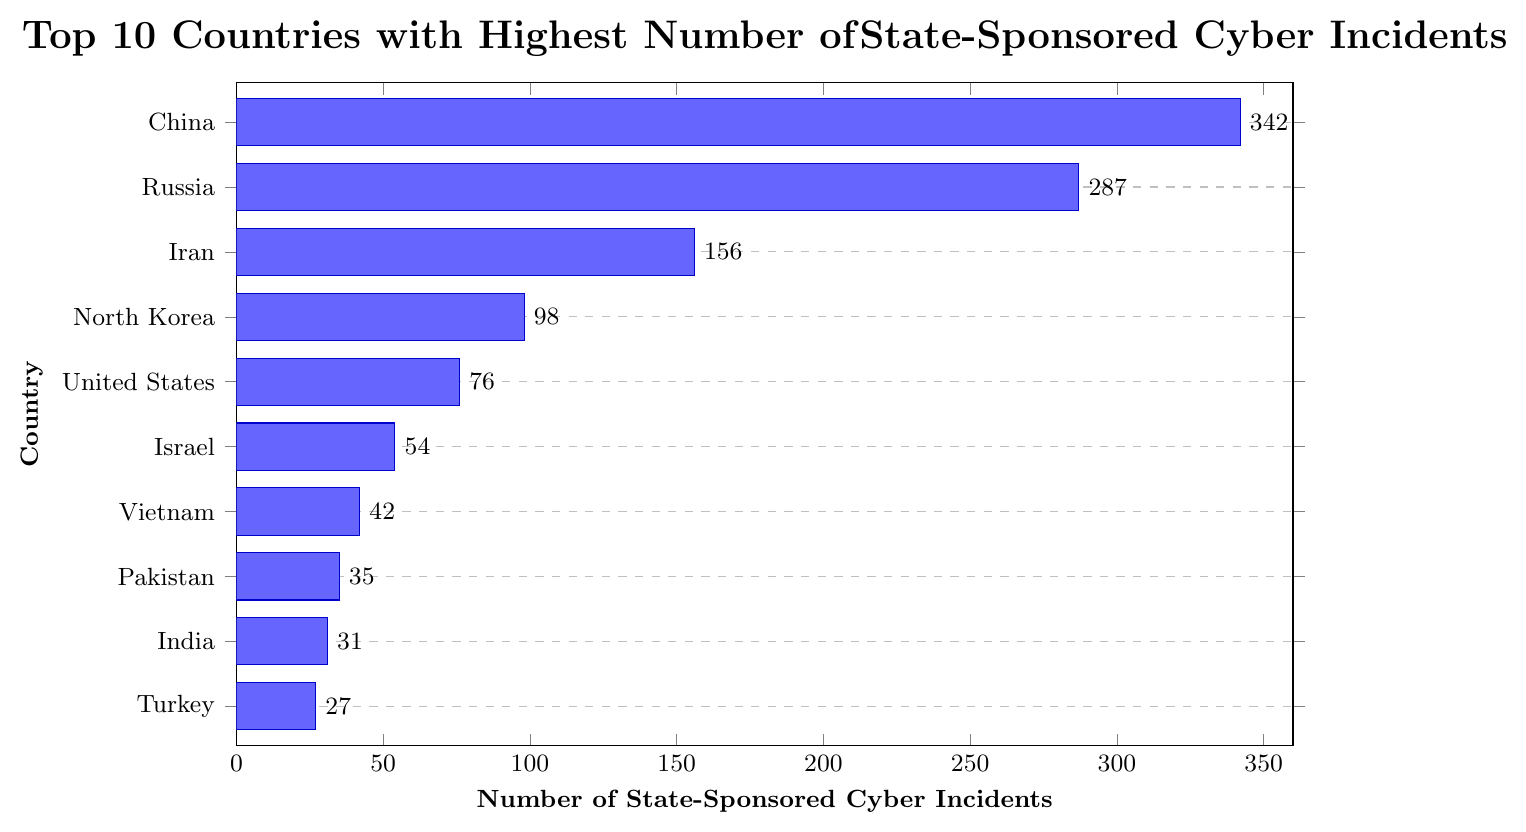What's the total number of state-sponsored cyber incidents for the top three countries? Add the number of incidents for China, Russia, and Iran: 342 (China) + 287 (Russia) + 156 (Iran) = 785
Answer: 785 Which country has more state-sponsored cyber incidents, Iran or North Korea? Iran has 156 incidents and North Korea has 98 incidents. Comparing these values, 156 is greater than 98
Answer: Iran What is the average number of state-sponsored cyber incidents for the top five countries? The top five countries are China, Russia, Iran, North Korea, and the United States. Sum their incidents: 342 + 287 + 156 + 98 + 76 = 959. Divide by 5: 959 / 5 = 191.8
Answer: 191.8 Which country has the lowest number of incidents among the top 10 countries listed? The country with the lowest number of incidents among the top 10 is Turkey, with 27 incidents
Answer: Turkey How many more incidents does China have compared to the United States? China has 342 incidents and the United States has 76 incidents. Subtract the number for the United States from the number for China: 342 - 76 = 266
Answer: 266 What is the difference in the number of incidents between Pakistan and Vietnam? Vietnam has 42 incidents and Pakistan has 35 incidents. Subtract the number for Pakistan from the number for Vietnam: 42 - 35 = 7
Answer: 7 If you combine the incidents of Israel and the United Kingdom, how does it compare to the number of incidents of Iran? Israel has 54 incidents and the United Kingdom has 21 incidents. Sum these: 54 + 21 = 75. Compare this to Iran's 156 incidents: 75 is less than 156
Answer: Less What is the total number of state-sponsored cyber incidents reported by countries other than China? Sum the incidents for all countries except China: 287 (Russia) + 156 (Iran) + 98 (North Korea) + 76 (United States) + 54 (Israel) + 42 (Vietnam) + 35 (Pakistan) + 31 (India) + 27 (Turkey) = 806
Answer: 806 Does India have more or fewer incidents compared to Turkey? India has 31 incidents and Turkey has 27 incidents. Since 31 is greater than 27, India has more incidents
Answer: More 